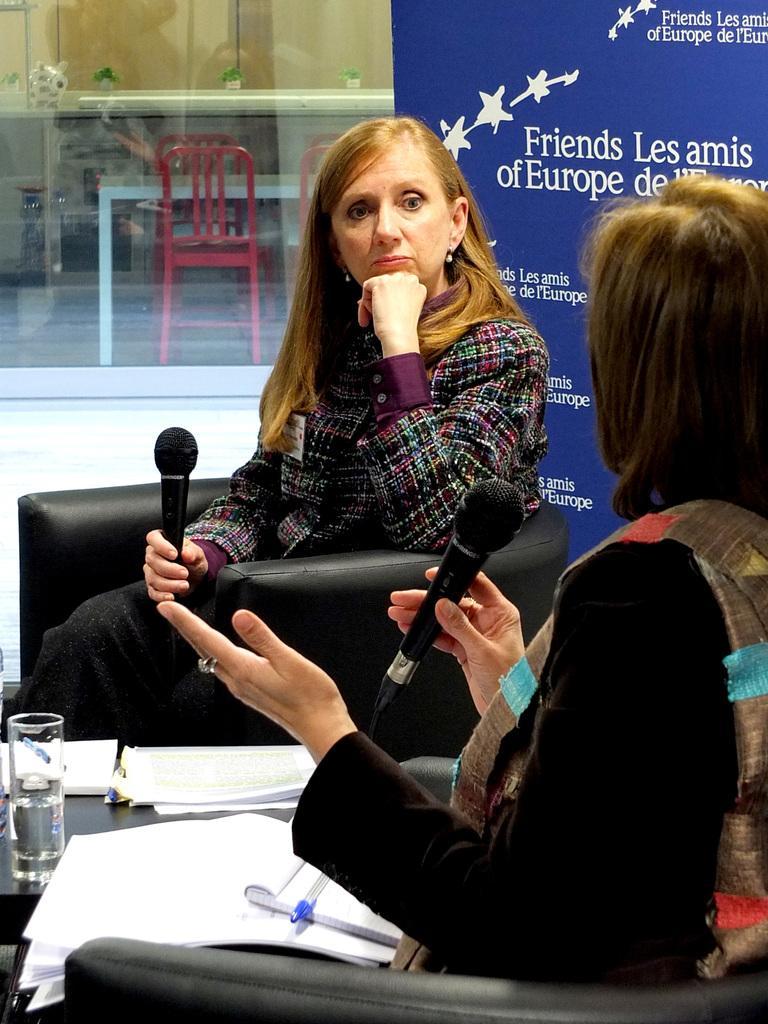How would you summarize this image in a sentence or two? this picture shows two women seated on the chairs and holding microphones in their hand and we see some papers and books and a glass on the table and we see a hoarding on their back 